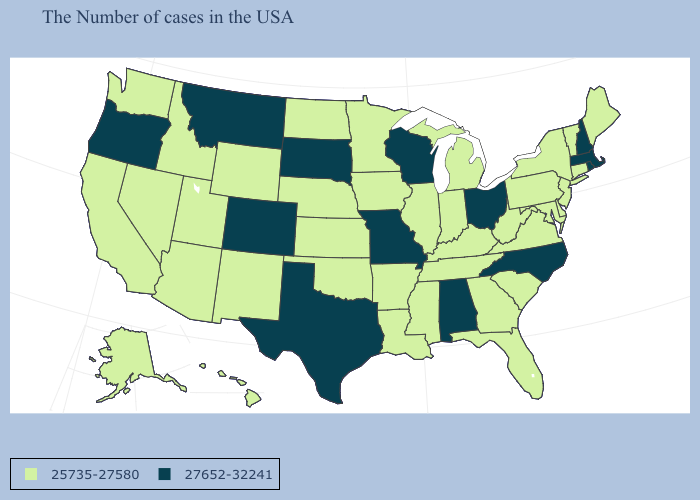Name the states that have a value in the range 25735-27580?
Answer briefly. Maine, Vermont, Connecticut, New York, New Jersey, Delaware, Maryland, Pennsylvania, Virginia, South Carolina, West Virginia, Florida, Georgia, Michigan, Kentucky, Indiana, Tennessee, Illinois, Mississippi, Louisiana, Arkansas, Minnesota, Iowa, Kansas, Nebraska, Oklahoma, North Dakota, Wyoming, New Mexico, Utah, Arizona, Idaho, Nevada, California, Washington, Alaska, Hawaii. Name the states that have a value in the range 27652-32241?
Answer briefly. Massachusetts, Rhode Island, New Hampshire, North Carolina, Ohio, Alabama, Wisconsin, Missouri, Texas, South Dakota, Colorado, Montana, Oregon. Does Nevada have the same value as Maryland?
Be succinct. Yes. Name the states that have a value in the range 27652-32241?
Keep it brief. Massachusetts, Rhode Island, New Hampshire, North Carolina, Ohio, Alabama, Wisconsin, Missouri, Texas, South Dakota, Colorado, Montana, Oregon. Which states have the lowest value in the West?
Write a very short answer. Wyoming, New Mexico, Utah, Arizona, Idaho, Nevada, California, Washington, Alaska, Hawaii. Name the states that have a value in the range 25735-27580?
Concise answer only. Maine, Vermont, Connecticut, New York, New Jersey, Delaware, Maryland, Pennsylvania, Virginia, South Carolina, West Virginia, Florida, Georgia, Michigan, Kentucky, Indiana, Tennessee, Illinois, Mississippi, Louisiana, Arkansas, Minnesota, Iowa, Kansas, Nebraska, Oklahoma, North Dakota, Wyoming, New Mexico, Utah, Arizona, Idaho, Nevada, California, Washington, Alaska, Hawaii. What is the value of Nebraska?
Short answer required. 25735-27580. What is the value of Vermont?
Quick response, please. 25735-27580. Name the states that have a value in the range 27652-32241?
Short answer required. Massachusetts, Rhode Island, New Hampshire, North Carolina, Ohio, Alabama, Wisconsin, Missouri, Texas, South Dakota, Colorado, Montana, Oregon. How many symbols are there in the legend?
Concise answer only. 2. Does Kentucky have the highest value in the USA?
Quick response, please. No. What is the value of Minnesota?
Answer briefly. 25735-27580. Does the first symbol in the legend represent the smallest category?
Write a very short answer. Yes. What is the value of Texas?
Give a very brief answer. 27652-32241. 